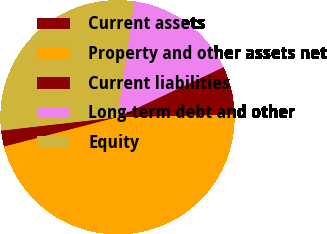<chart> <loc_0><loc_0><loc_500><loc_500><pie_chart><fcel>Current assets<fcel>Property and other assets net<fcel>Current liabilities<fcel>Long-term debt and other<fcel>Equity<nl><fcel>2.23%<fcel>46.35%<fcel>6.64%<fcel>15.69%<fcel>29.09%<nl></chart> 